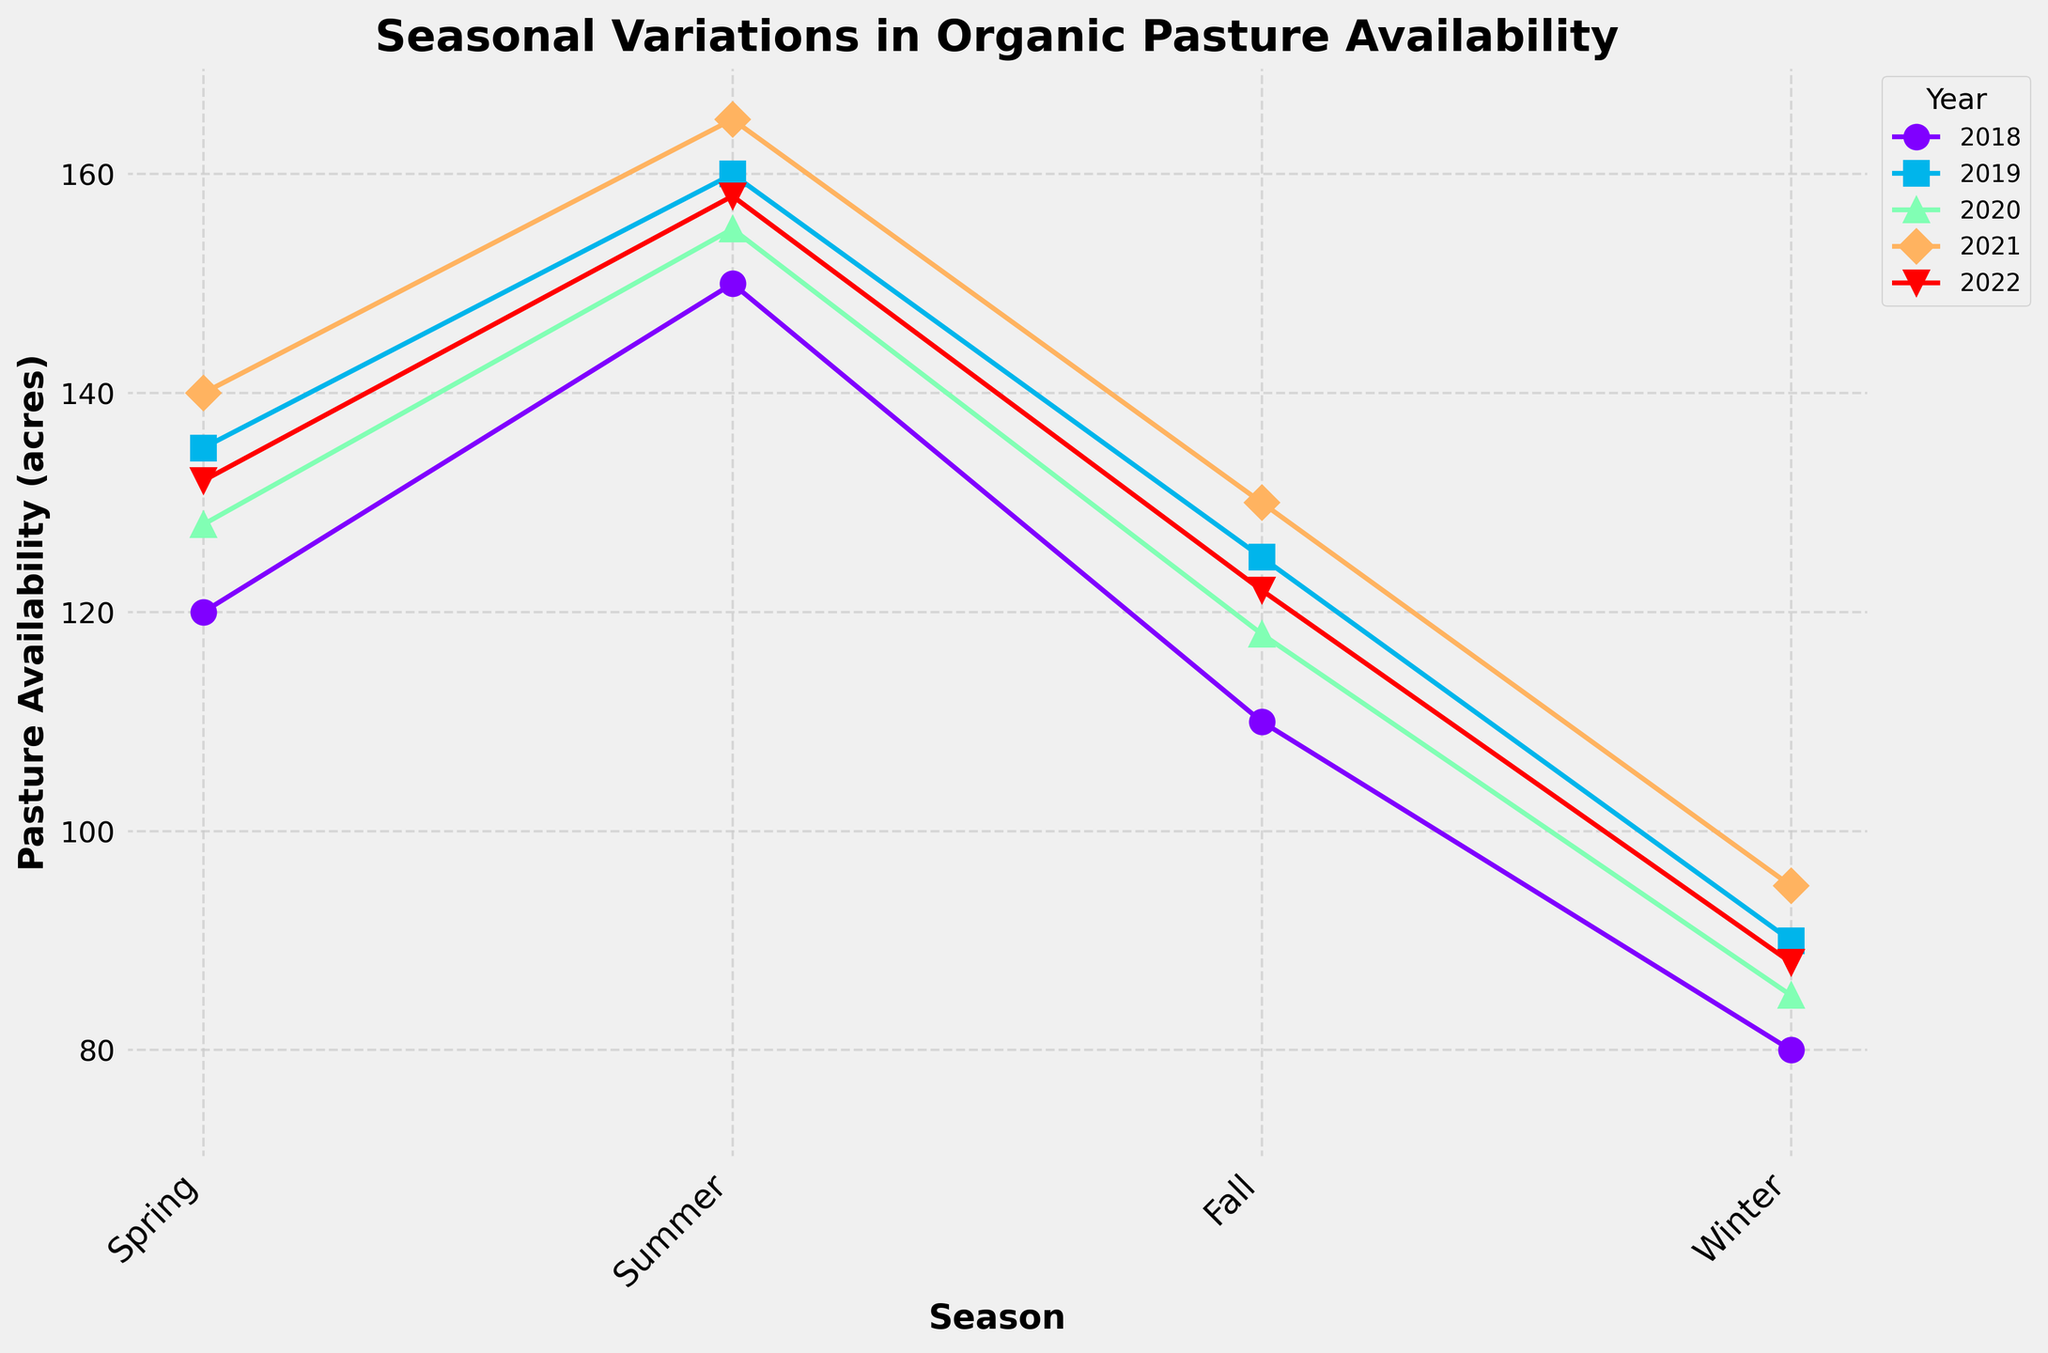What's the overall trend in pasture availability from Spring to Winter for each year? The pasture availability generally decreases from Spring to Winter each year. By scanning each year's data, we observe a drop from Spring or Summer to Winter consistently.
Answer: Decreasing Which year had the highest pasture availability in Spring? Look at the highest value for Spring among all years. The 2021 Spring value was 140, which is the highest in comparison with other years.
Answer: 2021 Is the protein content higher in Spring compared to Winter for most years? Across multiple years, we can observe that protein content is higher in Spring compared to Winter. Each year shows a drop from Spring to Winter in protein content.
Answer: Yes Which season has the least variation in pasture availability across different years? Comparing the range of pasture availability values for each season, Winter has the least variation, fluctuating from 80 to 95 acres across all years, which is less variation compared to other seasons.
Answer: Winter What is the average pasture availability for Spring over all years? To find the average, sum up the Spring values (120 + 135 + 128 + 140 + 132) and divide by the number of values (5). The total is 655, so the average is 655/5 = 131.
Answer: 131 Which year exhibits the greatest decrease in pasture availability from Summer to Winter? Calculate the differences for each year and compare: 
2018: 150 - 80 = 70,
2019: 160 - 90 = 70,
2020: 155 - 85 = 70,
2021: 165 - 95 = 70,
2022: 158 - 88 = 70.
All years have the same decrease, which is 70.
Answer: All years In which season did all years have the protein content below 17%? Check protein content for each season across all years. In Fall and Winter, all values are below 17%.
Answer: Fall, Winter How does the winter pasture availability in 2021 compare to 2018? Comparing the two values directly, the winter pasture availability in 2021 (95 acres) is greater than in 2018 (80 acres).
Answer: Greater Which two consecutive seasons have the smallest change in pasture availability in 2022? Calculate the changes between consecutive seasons in 2022:
Spring to Summer: 158 - 132 = 26,
Summer to Fall: 158 - 122 = 36,
Fall to Winter: 122 - 88 = 34.
The smallest change is from Spring to Summer (26 acres).
Answer: Spring to Summer What was the average protein content for the years 2020 and 2021 in Summer? Average the summer values for 2020 (16.8%) and 2021 (17.2%). Sum is (16.8 + 17.2)=34, and the average is 34/2=17.
Answer: 17 